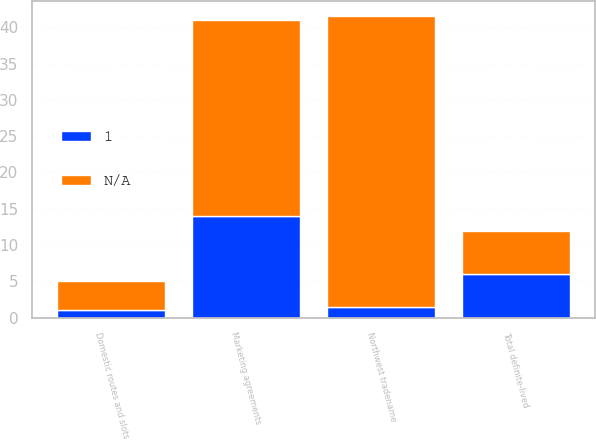Convert chart to OTSL. <chart><loc_0><loc_0><loc_500><loc_500><stacked_bar_chart><ecel><fcel>Northwest tradename<fcel>Marketing agreements<fcel>Domestic routes and slots<fcel>Total definite-lived<nl><fcel>1<fcel>1.5<fcel>14<fcel>1<fcel>6<nl><fcel>nan<fcel>40<fcel>27<fcel>4<fcel>6<nl></chart> 